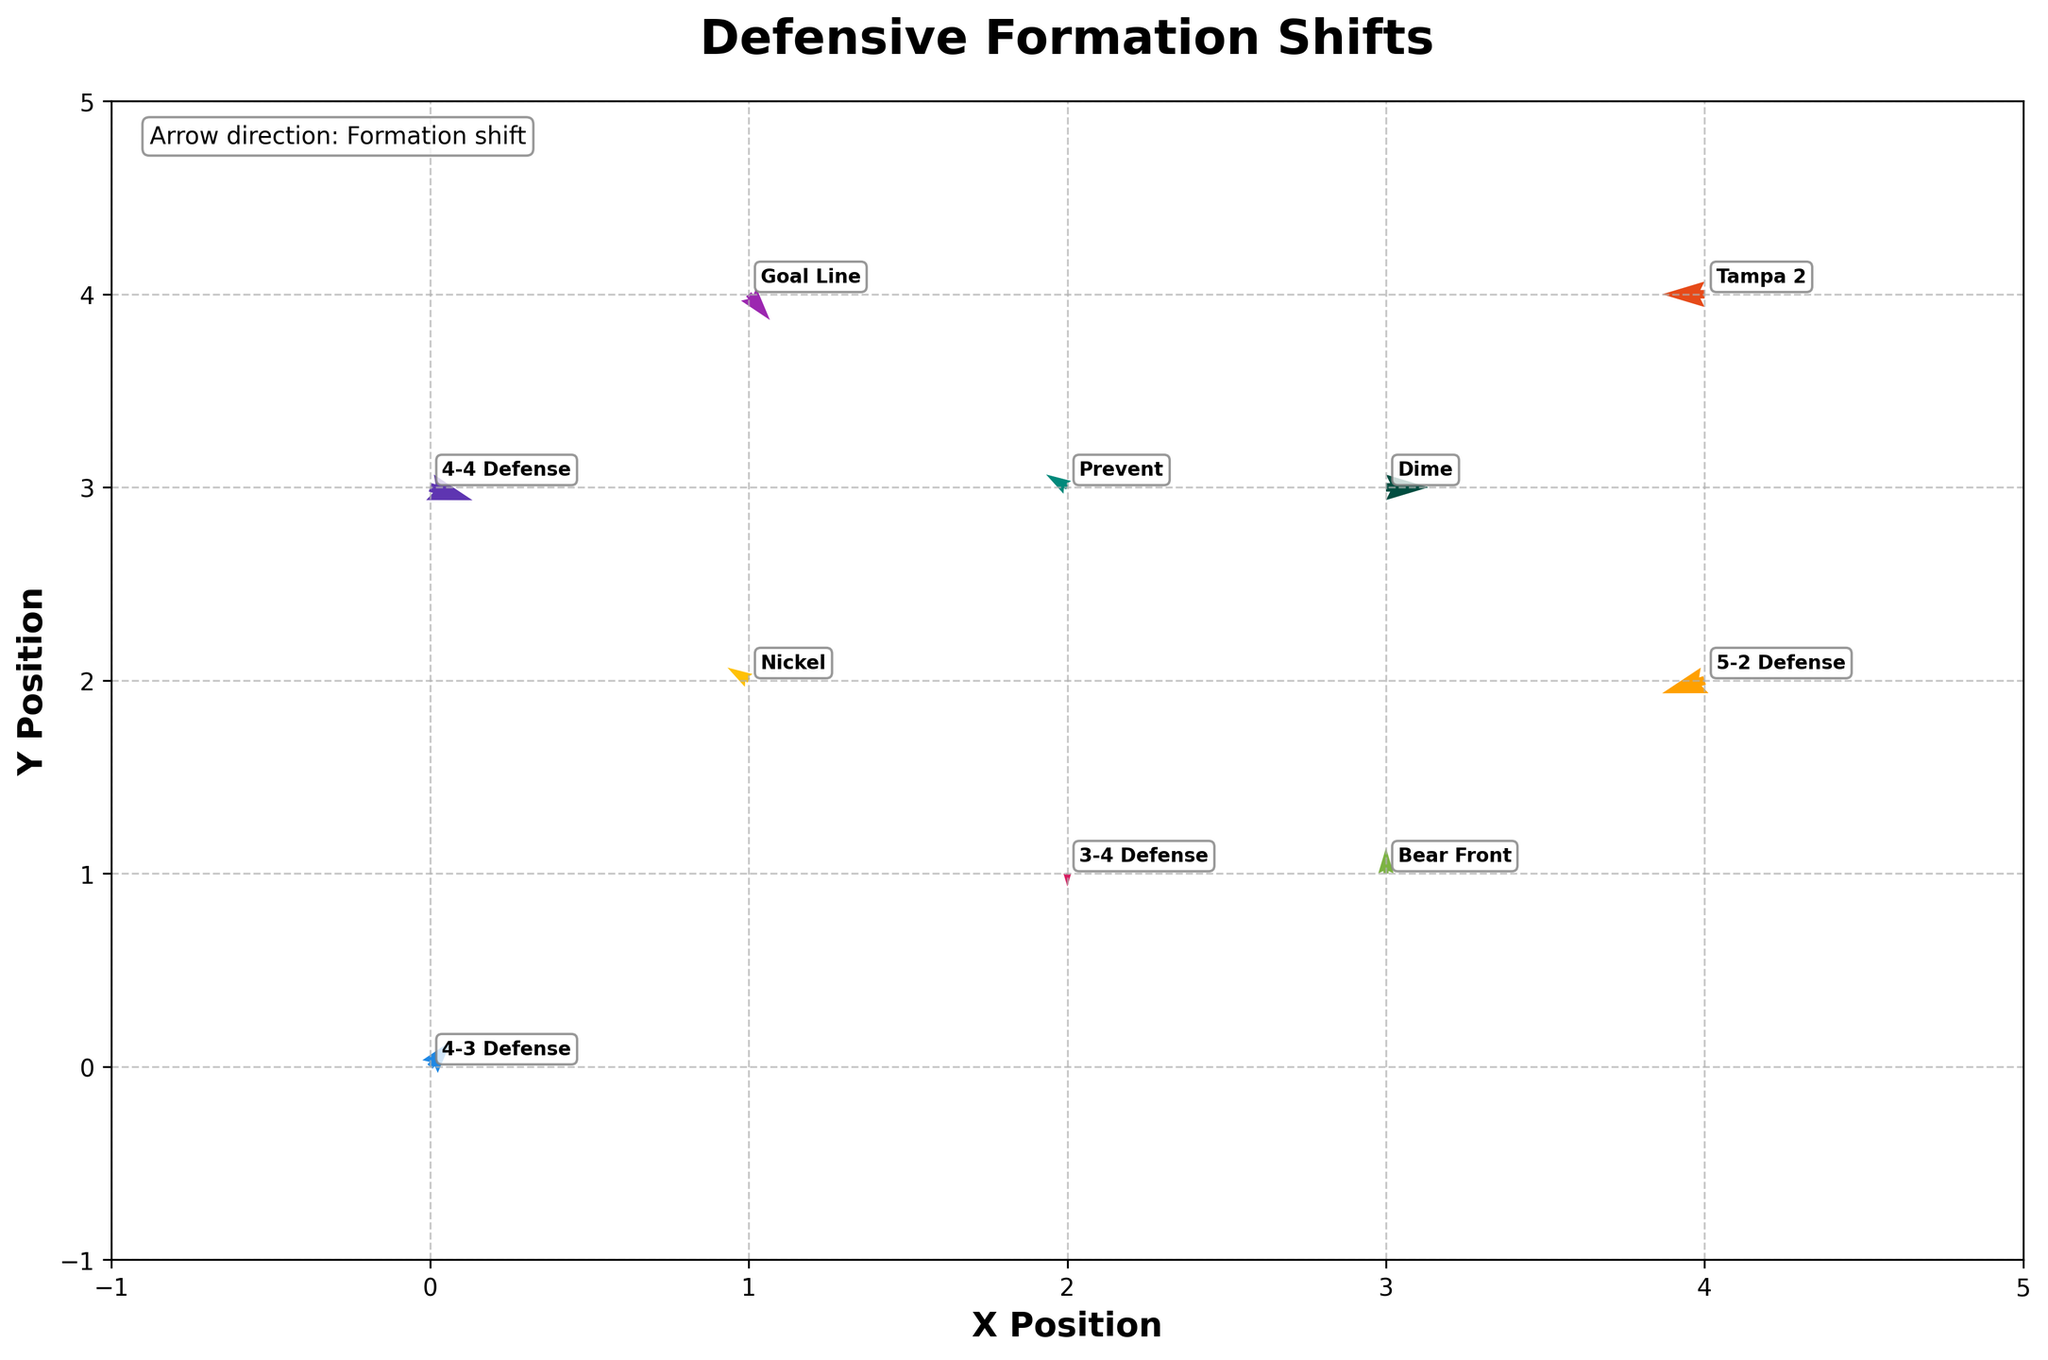how many defensive formations are shown in the figure? Count the number of unique formation names labeled in the figure
Answer: 10 which defensive formation shifts upward from its original position? Identify the arrows with a positive value in the Y direction (v). The arrows representing 4-3 Defense, Nickel, Bear Front, and Prevent formations have a positive Y component
Answer: 4-3 Defense, Nickel, Bear Front, and Prevent which formation stays at the same vertical level but shifts horizontally? Find the formations with a vertical shift (v) of 0. The Dime and Tampa 2 formations meet this criterion
Answer: Dime and Tampa 2 what is the total horizontal shift for the formations moving to the left? Add up the absolute values of the horizontal shifts (u) where the u value is negative. The 5-2 Defense, Goal Line, Prevent, and Tampa 2 formations have horizontal shifts of (-2) + (-2) + (-1) + (-2) = -7, so the total horizontal shift is 7
Answer: 7 which two formations have the most significant shift in any direction? Calculate the magnitude of the shift for each formation using √(u² + v²) and compare. The 4-3 Defense with √(1² + 2²) and Goal Line with √(1² + (-2)²) have the highest magnitudes
Answer: 4-3 Defense and Goal Line based on the arrows' direction, which formations shift downward? Identify the arrows with a negative value in the Y direction (v). The 4-4 Defense, 5-2 Defense, and Goal Line formations shift downward
Answer: 4-4 Defense, 5-2 Defense, and Goal Line which formations are located at the origin or the (0,0) point on the plot? Check the starting points of the formations. The 4-3 Defense formation starts at (0,0)
Answer: 4-3 Defense how many formations shift to the right? Count the formations with a positive value in the X direction (u). The 4-3 Defense, Dime, Goal Line, and Bear Front formations shift to the right
Answer: 4 